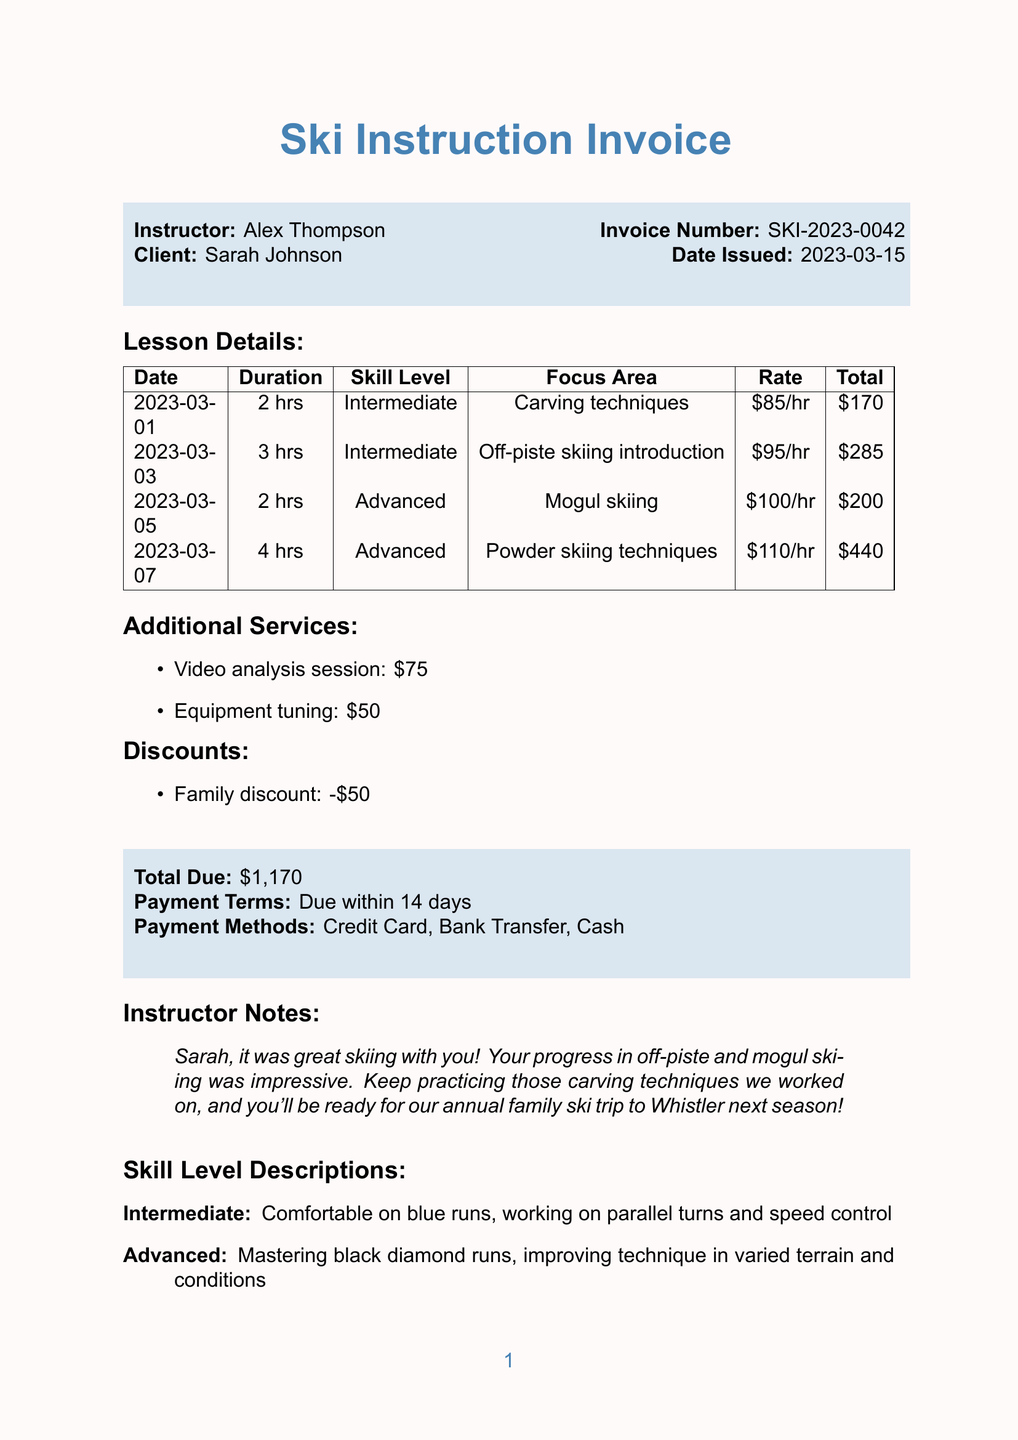what is the invoice number? The invoice number is specified in the document header.
Answer: SKI-2023-0042 who is the instructor? The instructor's name is provided at the top of the invoice.
Answer: Alex Thompson what is the total due amount? The total due is calculated from the lesson details minus discounts and additional services.
Answer: $1,170 how many hours of lessons did Sarah take on March 3rd? The duration of the lessons for that date can be found in the lesson details table.
Answer: 3 hrs what skill level was covered on March 5th? The skill level for that date is detailed in the lesson details section.
Answer: Advanced what was the focus area for the lesson on March 1st? The focus area for that lesson is mentioned in the corresponding lesson’s row.
Answer: Carving techniques what discount was applied to the invoice? The document lists the discount type applied in its discounts section.
Answer: Family discount which payment methods are accepted? The payment methods are enumerated in the payment terms section of the document.
Answer: Credit Card, Bank Transfer, Cash where was the lesson conducted? The location information section specifies where the lesson took place.
Answer: Aspen Snowmass 